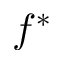Convert formula to latex. <formula><loc_0><loc_0><loc_500><loc_500>f ^ { \ast }</formula> 